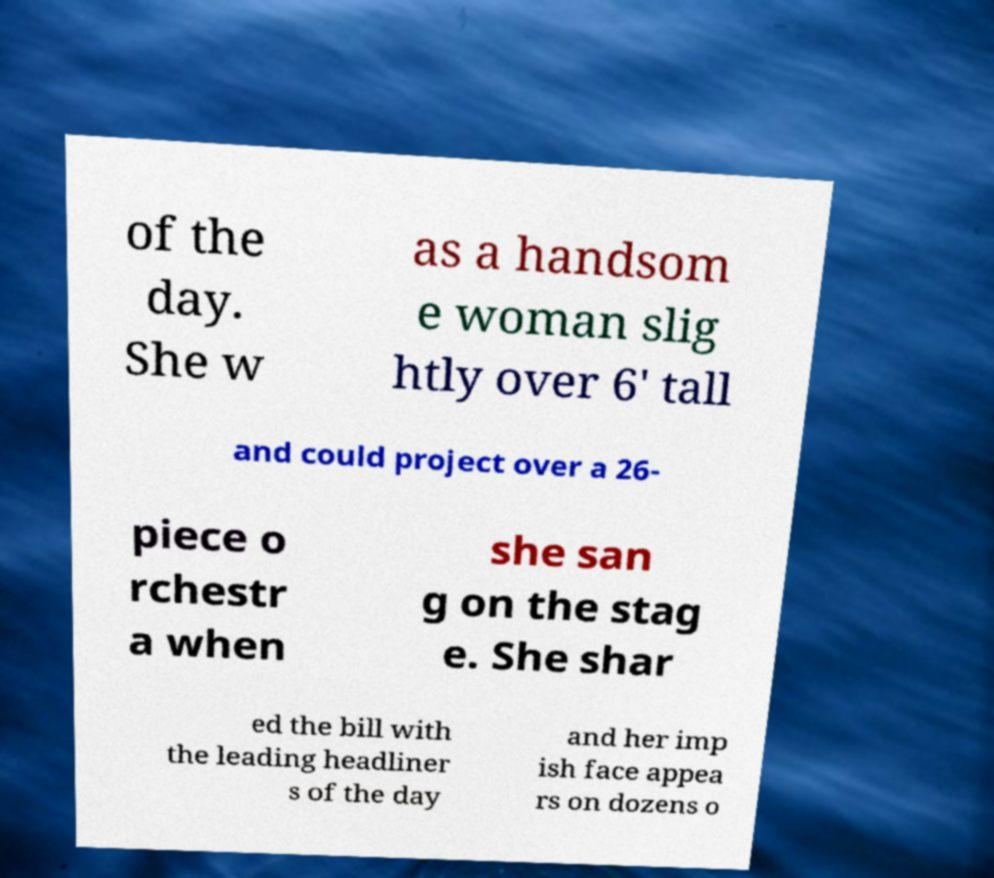Can you read and provide the text displayed in the image?This photo seems to have some interesting text. Can you extract and type it out for me? of the day. She w as a handsom e woman slig htly over 6' tall and could project over a 26- piece o rchestr a when she san g on the stag e. She shar ed the bill with the leading headliner s of the day and her imp ish face appea rs on dozens o 